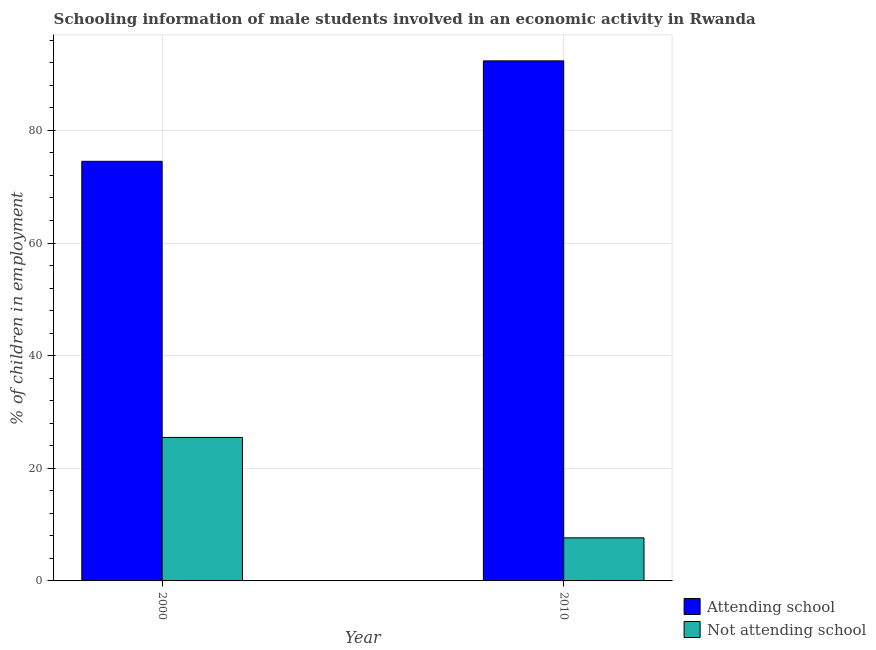How many groups of bars are there?
Your answer should be compact. 2. How many bars are there on the 2nd tick from the left?
Keep it short and to the point. 2. What is the label of the 2nd group of bars from the left?
Offer a very short reply. 2010. In how many cases, is the number of bars for a given year not equal to the number of legend labels?
Your answer should be very brief. 0. What is the percentage of employed males who are attending school in 2010?
Provide a short and direct response. 92.35. Across all years, what is the maximum percentage of employed males who are attending school?
Provide a short and direct response. 92.35. Across all years, what is the minimum percentage of employed males who are not attending school?
Offer a terse response. 7.65. What is the total percentage of employed males who are attending school in the graph?
Provide a succinct answer. 166.87. What is the difference between the percentage of employed males who are attending school in 2000 and that in 2010?
Your answer should be very brief. -17.83. What is the difference between the percentage of employed males who are attending school in 2010 and the percentage of employed males who are not attending school in 2000?
Keep it short and to the point. 17.83. What is the average percentage of employed males who are attending school per year?
Make the answer very short. 83.43. What is the ratio of the percentage of employed males who are attending school in 2000 to that in 2010?
Your answer should be compact. 0.81. In how many years, is the percentage of employed males who are not attending school greater than the average percentage of employed males who are not attending school taken over all years?
Make the answer very short. 1. What does the 1st bar from the left in 2000 represents?
Your answer should be compact. Attending school. What does the 1st bar from the right in 2010 represents?
Ensure brevity in your answer.  Not attending school. Are all the bars in the graph horizontal?
Provide a succinct answer. No. How many years are there in the graph?
Your response must be concise. 2. Does the graph contain any zero values?
Your answer should be very brief. No. Does the graph contain grids?
Keep it short and to the point. Yes. Where does the legend appear in the graph?
Keep it short and to the point. Bottom right. What is the title of the graph?
Offer a terse response. Schooling information of male students involved in an economic activity in Rwanda. Does "Fertility rate" appear as one of the legend labels in the graph?
Offer a very short reply. No. What is the label or title of the X-axis?
Make the answer very short. Year. What is the label or title of the Y-axis?
Give a very brief answer. % of children in employment. What is the % of children in employment of Attending school in 2000?
Your answer should be very brief. 74.52. What is the % of children in employment in Not attending school in 2000?
Your answer should be very brief. 25.48. What is the % of children in employment in Attending school in 2010?
Give a very brief answer. 92.35. What is the % of children in employment of Not attending school in 2010?
Provide a succinct answer. 7.65. Across all years, what is the maximum % of children in employment in Attending school?
Your response must be concise. 92.35. Across all years, what is the maximum % of children in employment in Not attending school?
Keep it short and to the point. 25.48. Across all years, what is the minimum % of children in employment in Attending school?
Provide a succinct answer. 74.52. Across all years, what is the minimum % of children in employment of Not attending school?
Provide a succinct answer. 7.65. What is the total % of children in employment of Attending school in the graph?
Your answer should be compact. 166.87. What is the total % of children in employment of Not attending school in the graph?
Provide a succinct answer. 33.13. What is the difference between the % of children in employment in Attending school in 2000 and that in 2010?
Your answer should be very brief. -17.83. What is the difference between the % of children in employment of Not attending school in 2000 and that in 2010?
Provide a succinct answer. 17.83. What is the difference between the % of children in employment in Attending school in 2000 and the % of children in employment in Not attending school in 2010?
Provide a short and direct response. 66.87. What is the average % of children in employment in Attending school per year?
Your answer should be very brief. 83.43. What is the average % of children in employment of Not attending school per year?
Provide a succinct answer. 16.57. In the year 2000, what is the difference between the % of children in employment in Attending school and % of children in employment in Not attending school?
Your answer should be very brief. 49.03. In the year 2010, what is the difference between the % of children in employment in Attending school and % of children in employment in Not attending school?
Keep it short and to the point. 84.7. What is the ratio of the % of children in employment of Attending school in 2000 to that in 2010?
Your answer should be compact. 0.81. What is the ratio of the % of children in employment of Not attending school in 2000 to that in 2010?
Offer a terse response. 3.33. What is the difference between the highest and the second highest % of children in employment in Attending school?
Your response must be concise. 17.83. What is the difference between the highest and the second highest % of children in employment in Not attending school?
Ensure brevity in your answer.  17.83. What is the difference between the highest and the lowest % of children in employment in Attending school?
Your answer should be very brief. 17.83. What is the difference between the highest and the lowest % of children in employment of Not attending school?
Your answer should be very brief. 17.83. 